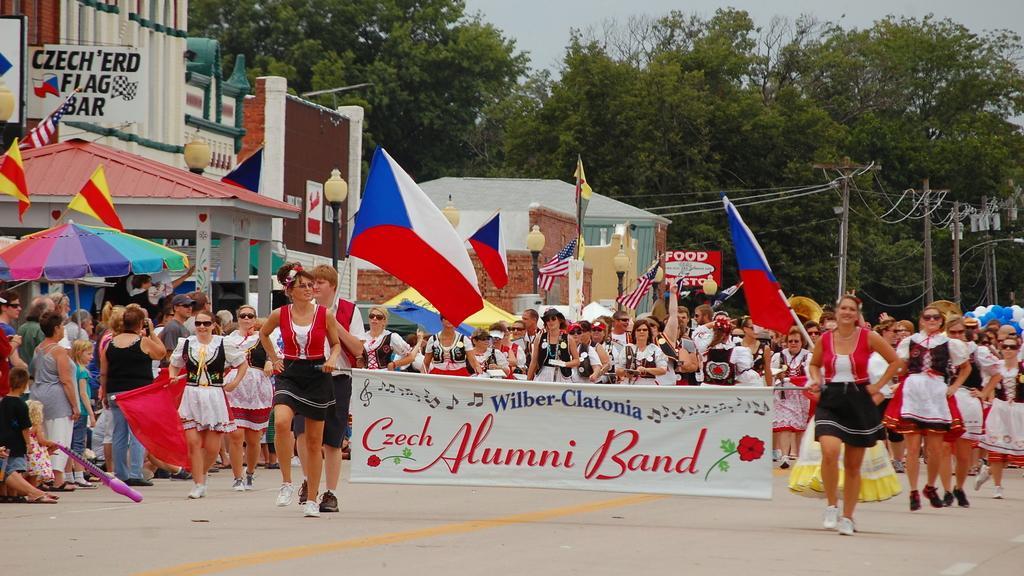Can you describe this image briefly? In this picture we can see some people are walking on the road and they are holding flags, banners. Beside we can see a few people are standing and watching. 